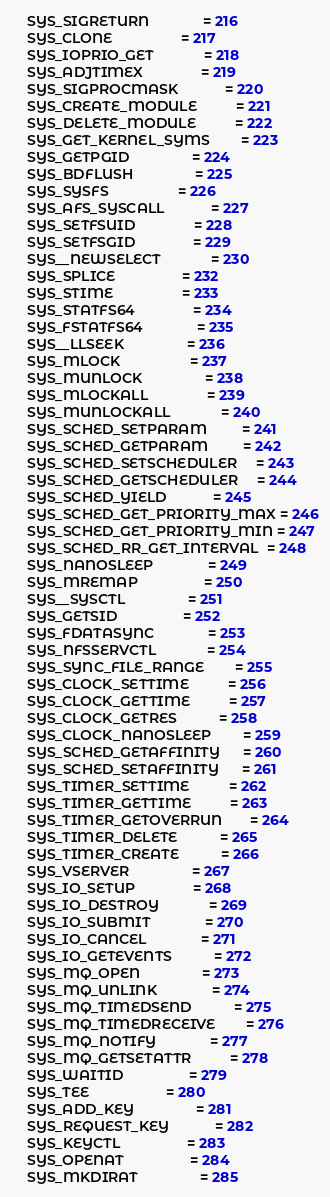Convert code to text. <code><loc_0><loc_0><loc_500><loc_500><_Go_>	SYS_SIGRETURN              = 216
	SYS_CLONE                  = 217
	SYS_IOPRIO_GET             = 218
	SYS_ADJTIMEX               = 219
	SYS_SIGPROCMASK            = 220
	SYS_CREATE_MODULE          = 221
	SYS_DELETE_MODULE          = 222
	SYS_GET_KERNEL_SYMS        = 223
	SYS_GETPGID                = 224
	SYS_BDFLUSH                = 225
	SYS_SYSFS                  = 226
	SYS_AFS_SYSCALL            = 227
	SYS_SETFSUID               = 228
	SYS_SETFSGID               = 229
	SYS__NEWSELECT             = 230
	SYS_SPLICE                 = 232
	SYS_STIME                  = 233
	SYS_STATFS64               = 234
	SYS_FSTATFS64              = 235
	SYS__LLSEEK                = 236
	SYS_MLOCK                  = 237
	SYS_MUNLOCK                = 238
	SYS_MLOCKALL               = 239
	SYS_MUNLOCKALL             = 240
	SYS_SCHED_SETPARAM         = 241
	SYS_SCHED_GETPARAM         = 242
	SYS_SCHED_SETSCHEDULER     = 243
	SYS_SCHED_GETSCHEDULER     = 244
	SYS_SCHED_YIELD            = 245
	SYS_SCHED_GET_PRIORITY_MAX = 246
	SYS_SCHED_GET_PRIORITY_MIN = 247
	SYS_SCHED_RR_GET_INTERVAL  = 248
	SYS_NANOSLEEP              = 249
	SYS_MREMAP                 = 250
	SYS__SYSCTL                = 251
	SYS_GETSID                 = 252
	SYS_FDATASYNC              = 253
	SYS_NFSSERVCTL             = 254
	SYS_SYNC_FILE_RANGE        = 255
	SYS_CLOCK_SETTIME          = 256
	SYS_CLOCK_GETTIME          = 257
	SYS_CLOCK_GETRES           = 258
	SYS_CLOCK_NANOSLEEP        = 259
	SYS_SCHED_GETAFFINITY      = 260
	SYS_SCHED_SETAFFINITY      = 261
	SYS_TIMER_SETTIME          = 262
	SYS_TIMER_GETTIME          = 263
	SYS_TIMER_GETOVERRUN       = 264
	SYS_TIMER_DELETE           = 265
	SYS_TIMER_CREATE           = 266
	SYS_VSERVER                = 267
	SYS_IO_SETUP               = 268
	SYS_IO_DESTROY             = 269
	SYS_IO_SUBMIT              = 270
	SYS_IO_CANCEL              = 271
	SYS_IO_GETEVENTS           = 272
	SYS_MQ_OPEN                = 273
	SYS_MQ_UNLINK              = 274
	SYS_MQ_TIMEDSEND           = 275
	SYS_MQ_TIMEDRECEIVE        = 276
	SYS_MQ_NOTIFY              = 277
	SYS_MQ_GETSETATTR          = 278
	SYS_WAITID                 = 279
	SYS_TEE                    = 280
	SYS_ADD_KEY                = 281
	SYS_REQUEST_KEY            = 282
	SYS_KEYCTL                 = 283
	SYS_OPENAT                 = 284
	SYS_MKDIRAT                = 285</code> 